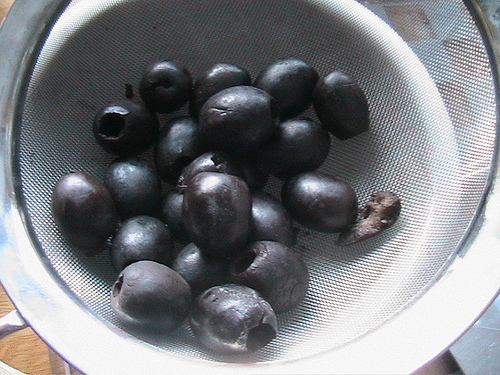<image>
Is there a olives under the olives? No. The olives is not positioned under the olives. The vertical relationship between these objects is different. 